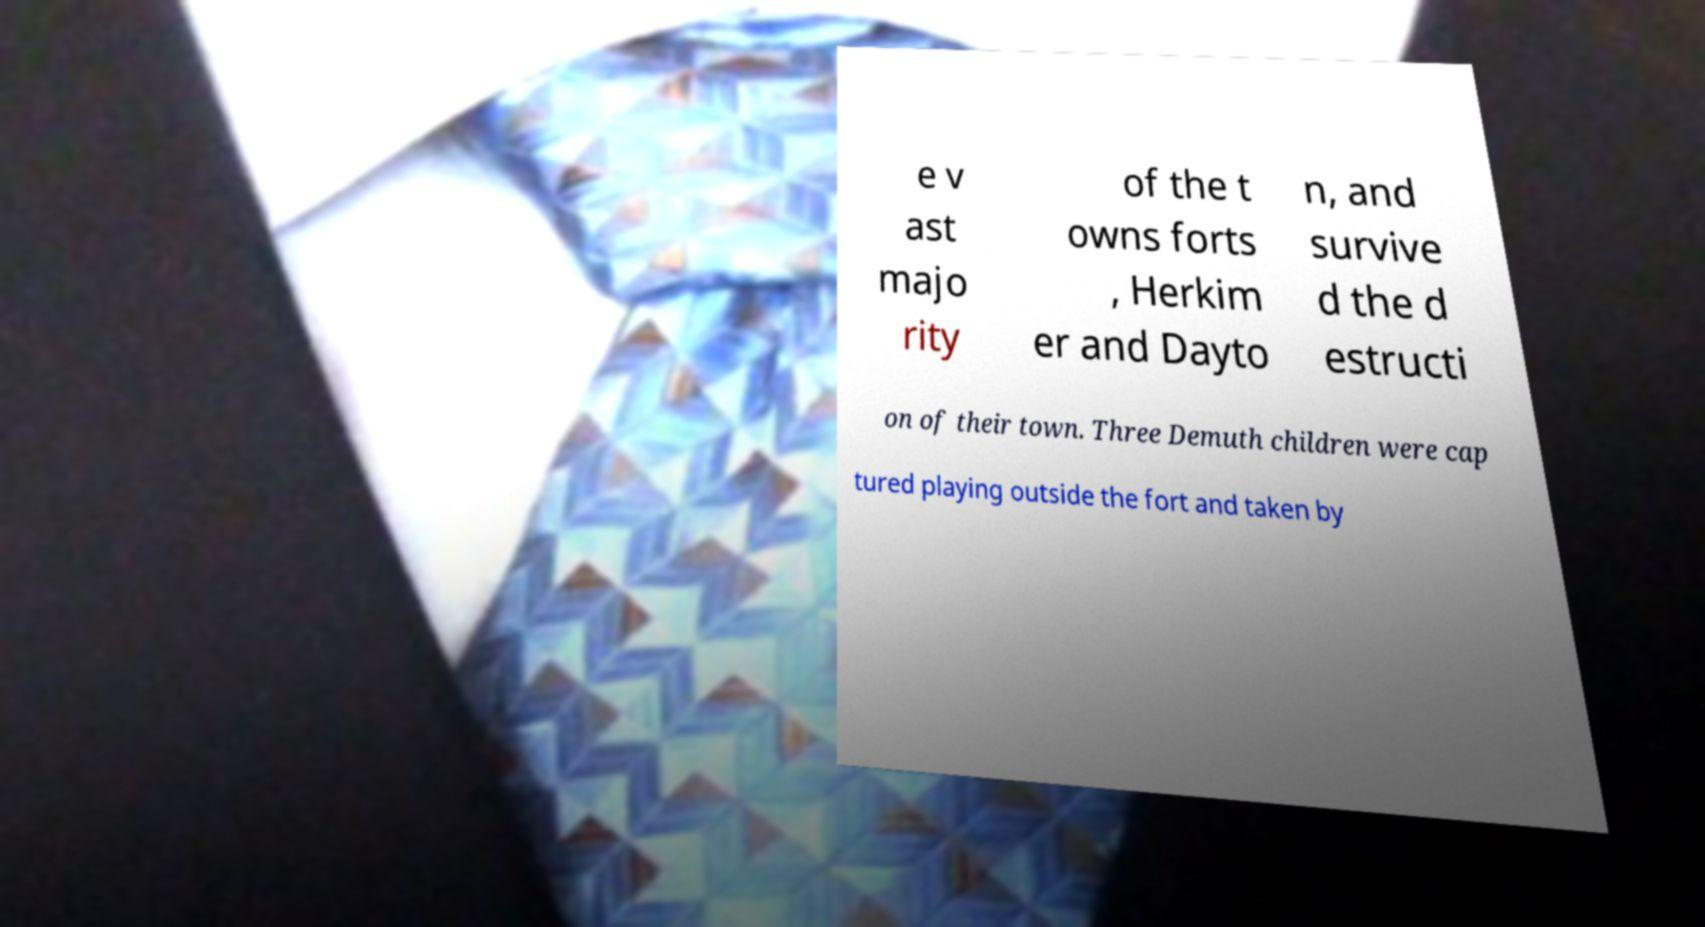Could you extract and type out the text from this image? e v ast majo rity of the t owns forts , Herkim er and Dayto n, and survive d the d estructi on of their town. Three Demuth children were cap tured playing outside the fort and taken by 